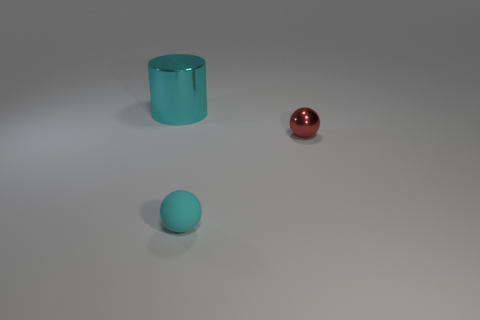Is there anything else that has the same size as the cylinder?
Your response must be concise. No. Are there fewer cyan metallic cylinders than small purple balls?
Make the answer very short. No. The object that is behind the tiny matte sphere and on the left side of the red shiny ball has what shape?
Keep it short and to the point. Cylinder. How many small brown shiny cubes are there?
Your answer should be compact. 0. There is a thing on the right side of the sphere that is in front of the shiny object that is in front of the large metallic cylinder; what is its material?
Keep it short and to the point. Metal. How many small things are left of the metallic object right of the tiny cyan matte sphere?
Offer a terse response. 1. What color is the tiny rubber object that is the same shape as the red metal object?
Provide a short and direct response. Cyan. Do the tiny red ball and the small cyan ball have the same material?
Keep it short and to the point. No. What number of cubes are small purple things or small rubber objects?
Keep it short and to the point. 0. There is a ball that is behind the tiny ball that is in front of the metallic object on the right side of the big metallic thing; what is its size?
Ensure brevity in your answer.  Small. 